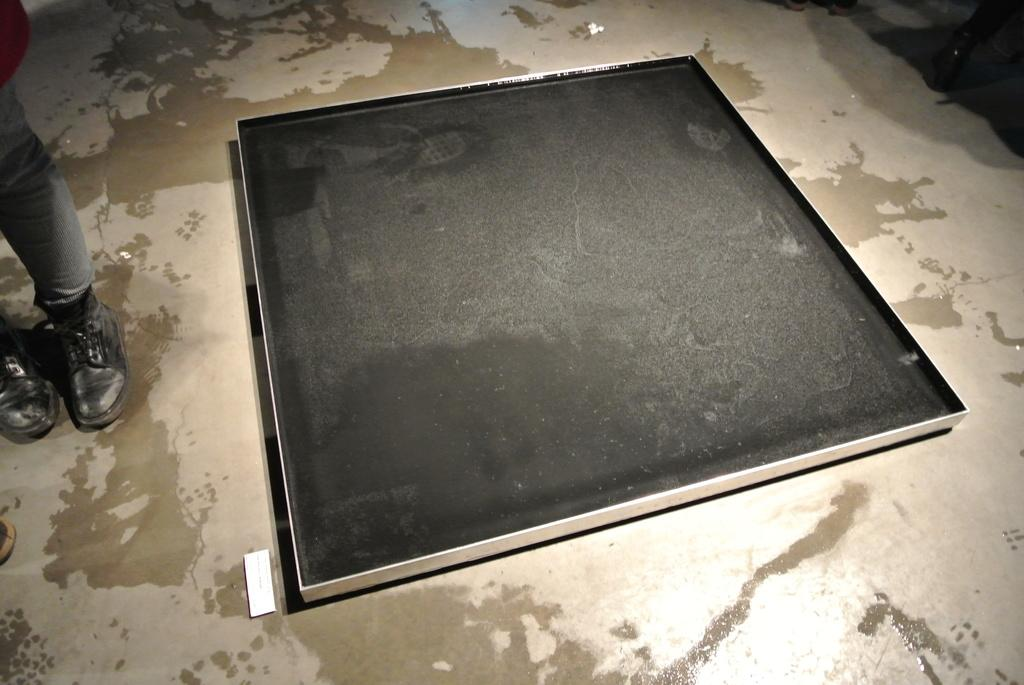What is on the floor in the image? There is a big tray on the floor in the image. What color is the tray? The tray is black in color. Can you see any part of a person in the image? Yes, there are legs of a person visible in the image. What type of footwear is the person wearing? The person is wearing shoes. What type of rail can be seen in the image? There is no rail present in the image. Can you tell me how many books are in the library depicted in the image? There is no library or books visible in the image. 